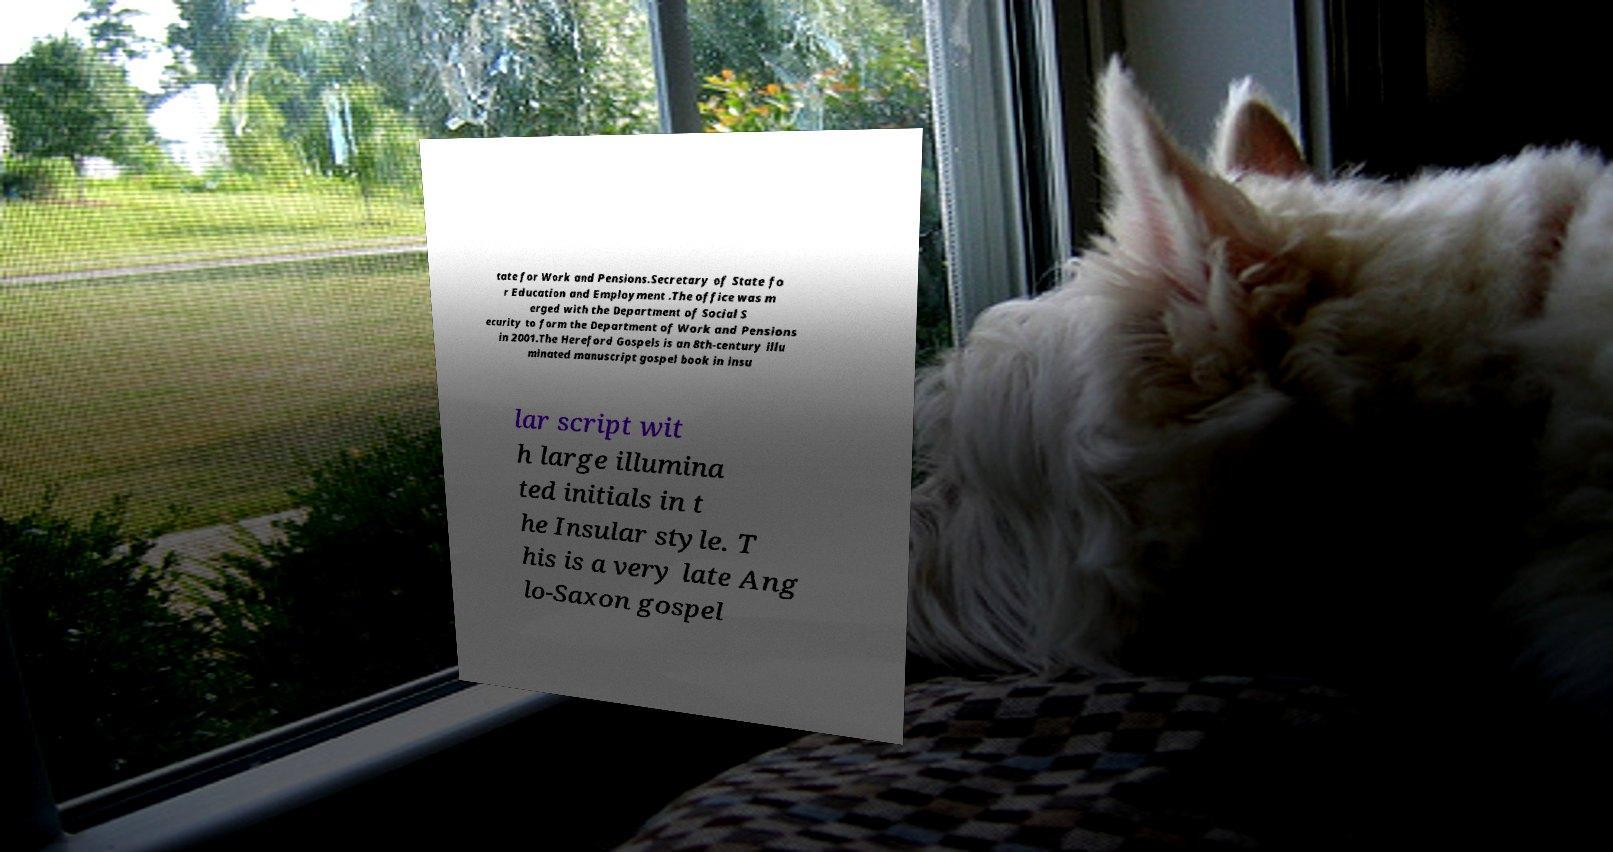Can you accurately transcribe the text from the provided image for me? tate for Work and Pensions.Secretary of State fo r Education and Employment .The office was m erged with the Department of Social S ecurity to form the Department of Work and Pensions in 2001.The Hereford Gospels is an 8th-century illu minated manuscript gospel book in insu lar script wit h large illumina ted initials in t he Insular style. T his is a very late Ang lo-Saxon gospel 